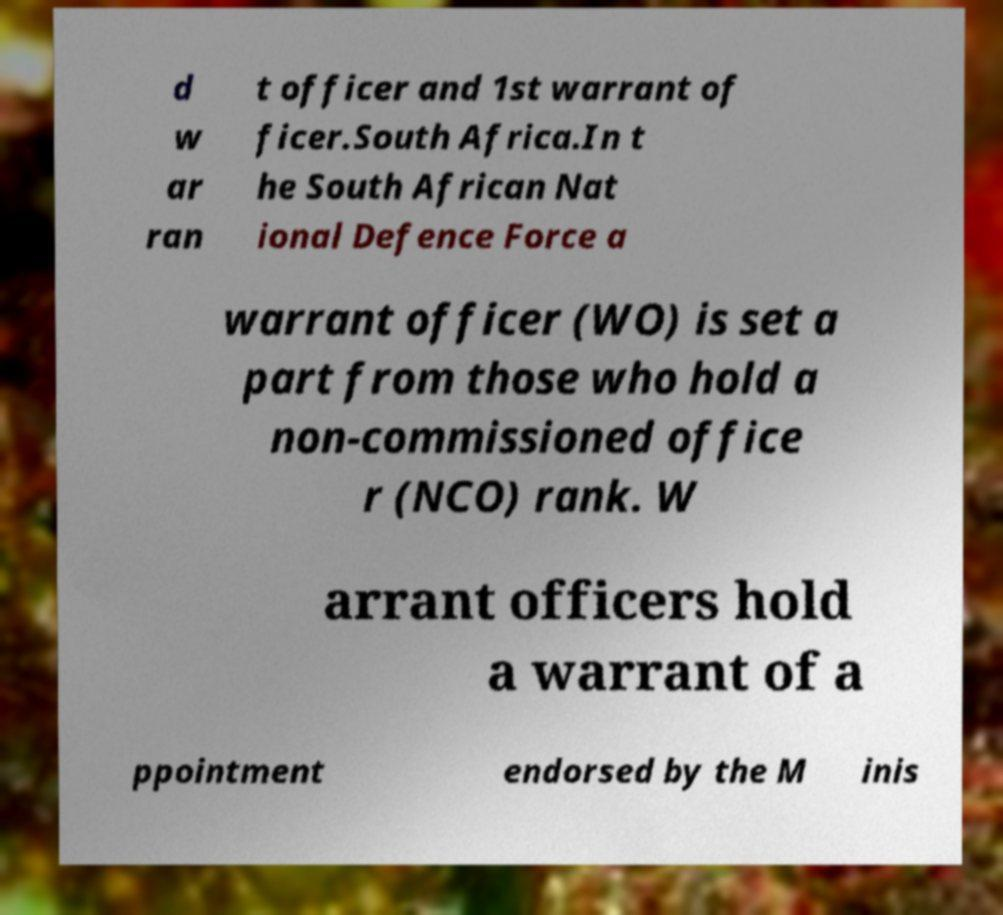I need the written content from this picture converted into text. Can you do that? d w ar ran t officer and 1st warrant of ficer.South Africa.In t he South African Nat ional Defence Force a warrant officer (WO) is set a part from those who hold a non-commissioned office r (NCO) rank. W arrant officers hold a warrant of a ppointment endorsed by the M inis 